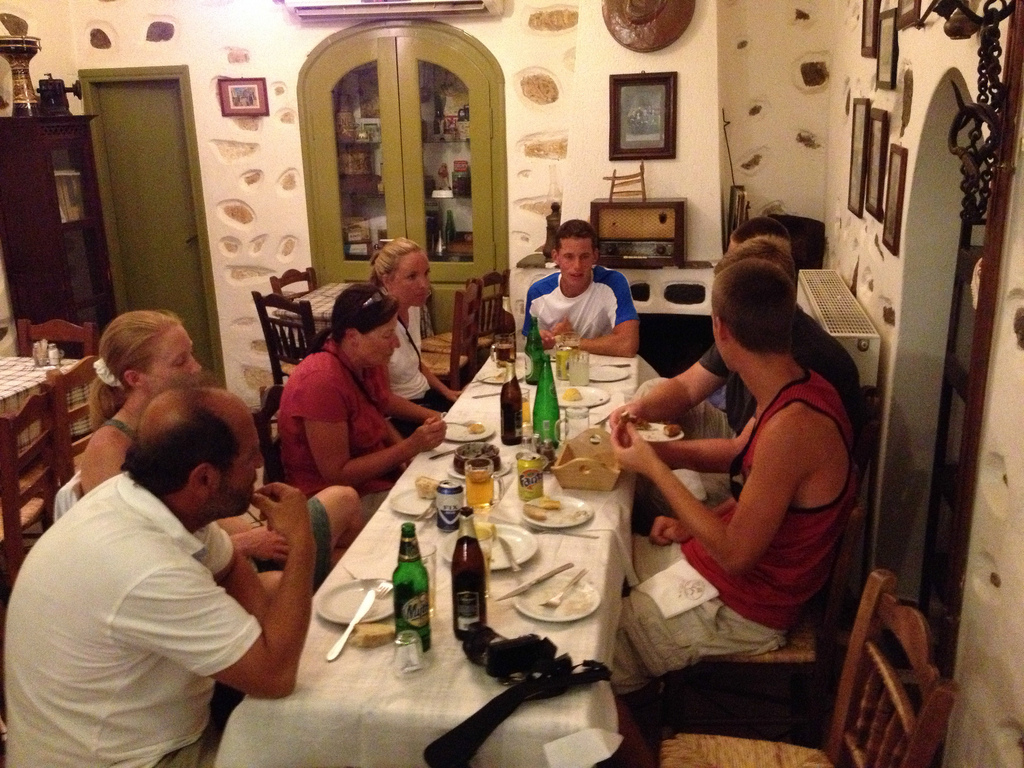Is the plate to the left or to the right of the napkin in the bottom? The plate is positioned to the left of the napkin at the bottom of the image, nestled among other dinnerware and utensils. 